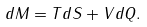<formula> <loc_0><loc_0><loc_500><loc_500>d M = T d S + V d Q .</formula> 